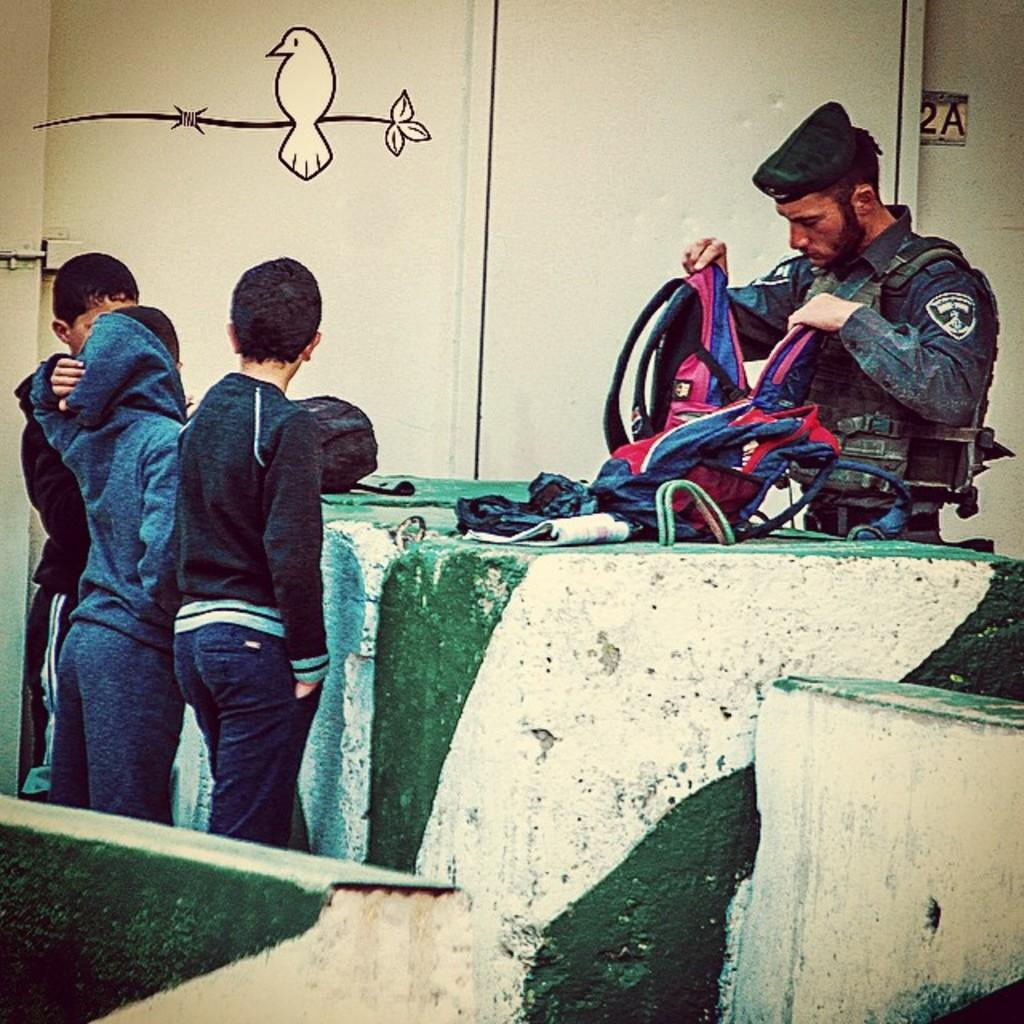How many people are in the image? There are four persons in the image. What is one person doing with their hands? One person is holding a bag with their hands. What is inside the bag? There are clothes in the bag. What can be seen in the background of the image? There is a wall in the background of the image. What is on the wall? There is a painting on the wall. What type of riddle can be solved by looking at the pot in the image? There is no pot present in the image, so no riddle can be solved by looking at a pot. What material is the metal used for in the image? There is no mention of metal in the image, so it is not possible to determine what material it might be used for. 